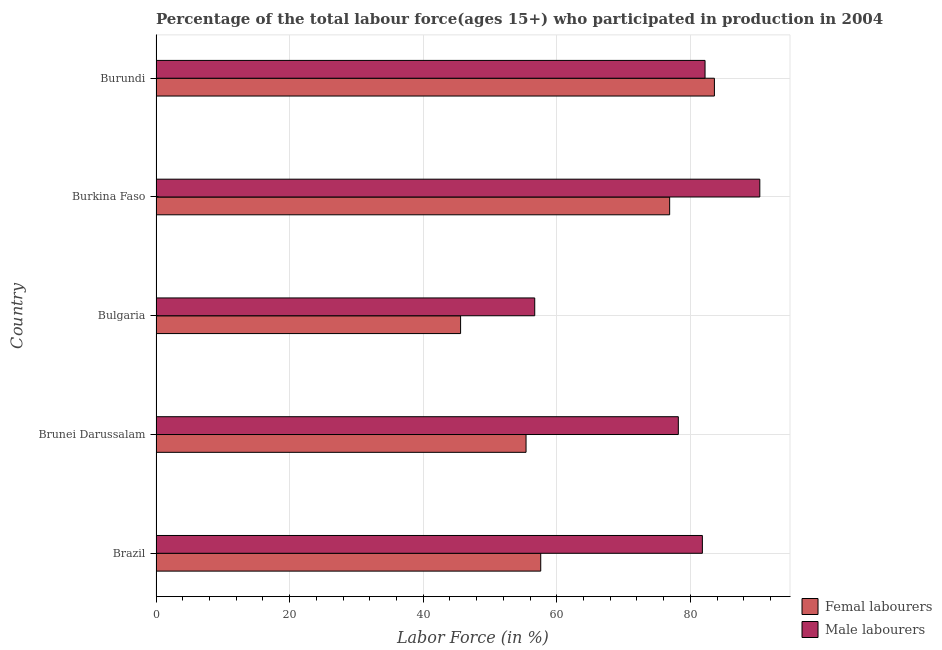How many different coloured bars are there?
Your response must be concise. 2. Are the number of bars per tick equal to the number of legend labels?
Offer a very short reply. Yes. How many bars are there on the 3rd tick from the bottom?
Give a very brief answer. 2. What is the label of the 2nd group of bars from the top?
Your answer should be compact. Burkina Faso. What is the percentage of female labor force in Burkina Faso?
Provide a short and direct response. 76.9. Across all countries, what is the maximum percentage of male labour force?
Provide a short and direct response. 90.4. Across all countries, what is the minimum percentage of female labor force?
Offer a terse response. 45.6. In which country was the percentage of female labor force maximum?
Your answer should be very brief. Burundi. What is the total percentage of male labour force in the graph?
Your answer should be compact. 389.3. What is the difference between the percentage of male labour force in Burkina Faso and that in Burundi?
Ensure brevity in your answer.  8.2. What is the difference between the percentage of female labor force in Burundi and the percentage of male labour force in Bulgaria?
Make the answer very short. 26.9. What is the average percentage of female labor force per country?
Offer a very short reply. 63.82. What is the ratio of the percentage of female labor force in Brazil to that in Burkina Faso?
Offer a terse response. 0.75. Is the percentage of male labour force in Brunei Darussalam less than that in Burundi?
Make the answer very short. Yes. What is the difference between the highest and the second highest percentage of female labor force?
Offer a very short reply. 6.7. What does the 1st bar from the top in Brazil represents?
Ensure brevity in your answer.  Male labourers. What does the 2nd bar from the bottom in Bulgaria represents?
Your answer should be compact. Male labourers. Are all the bars in the graph horizontal?
Your answer should be compact. Yes. How many countries are there in the graph?
Your response must be concise. 5. Are the values on the major ticks of X-axis written in scientific E-notation?
Ensure brevity in your answer.  No. How many legend labels are there?
Keep it short and to the point. 2. How are the legend labels stacked?
Provide a succinct answer. Vertical. What is the title of the graph?
Offer a terse response. Percentage of the total labour force(ages 15+) who participated in production in 2004. Does "Fertility rate" appear as one of the legend labels in the graph?
Ensure brevity in your answer.  No. What is the Labor Force (in %) in Femal labourers in Brazil?
Offer a very short reply. 57.6. What is the Labor Force (in %) in Male labourers in Brazil?
Make the answer very short. 81.8. What is the Labor Force (in %) of Femal labourers in Brunei Darussalam?
Your answer should be compact. 55.4. What is the Labor Force (in %) of Male labourers in Brunei Darussalam?
Provide a succinct answer. 78.2. What is the Labor Force (in %) of Femal labourers in Bulgaria?
Your response must be concise. 45.6. What is the Labor Force (in %) in Male labourers in Bulgaria?
Your response must be concise. 56.7. What is the Labor Force (in %) of Femal labourers in Burkina Faso?
Your answer should be very brief. 76.9. What is the Labor Force (in %) in Male labourers in Burkina Faso?
Offer a terse response. 90.4. What is the Labor Force (in %) in Femal labourers in Burundi?
Provide a succinct answer. 83.6. What is the Labor Force (in %) in Male labourers in Burundi?
Make the answer very short. 82.2. Across all countries, what is the maximum Labor Force (in %) of Femal labourers?
Keep it short and to the point. 83.6. Across all countries, what is the maximum Labor Force (in %) of Male labourers?
Offer a terse response. 90.4. Across all countries, what is the minimum Labor Force (in %) of Femal labourers?
Your answer should be compact. 45.6. Across all countries, what is the minimum Labor Force (in %) of Male labourers?
Keep it short and to the point. 56.7. What is the total Labor Force (in %) in Femal labourers in the graph?
Offer a terse response. 319.1. What is the total Labor Force (in %) of Male labourers in the graph?
Your response must be concise. 389.3. What is the difference between the Labor Force (in %) in Femal labourers in Brazil and that in Bulgaria?
Ensure brevity in your answer.  12. What is the difference between the Labor Force (in %) of Male labourers in Brazil and that in Bulgaria?
Provide a succinct answer. 25.1. What is the difference between the Labor Force (in %) in Femal labourers in Brazil and that in Burkina Faso?
Make the answer very short. -19.3. What is the difference between the Labor Force (in %) in Femal labourers in Brazil and that in Burundi?
Keep it short and to the point. -26. What is the difference between the Labor Force (in %) of Male labourers in Brazil and that in Burundi?
Offer a very short reply. -0.4. What is the difference between the Labor Force (in %) of Male labourers in Brunei Darussalam and that in Bulgaria?
Your answer should be very brief. 21.5. What is the difference between the Labor Force (in %) in Femal labourers in Brunei Darussalam and that in Burkina Faso?
Ensure brevity in your answer.  -21.5. What is the difference between the Labor Force (in %) of Femal labourers in Brunei Darussalam and that in Burundi?
Make the answer very short. -28.2. What is the difference between the Labor Force (in %) of Femal labourers in Bulgaria and that in Burkina Faso?
Make the answer very short. -31.3. What is the difference between the Labor Force (in %) in Male labourers in Bulgaria and that in Burkina Faso?
Provide a short and direct response. -33.7. What is the difference between the Labor Force (in %) in Femal labourers in Bulgaria and that in Burundi?
Keep it short and to the point. -38. What is the difference between the Labor Force (in %) of Male labourers in Bulgaria and that in Burundi?
Keep it short and to the point. -25.5. What is the difference between the Labor Force (in %) in Femal labourers in Brazil and the Labor Force (in %) in Male labourers in Brunei Darussalam?
Make the answer very short. -20.6. What is the difference between the Labor Force (in %) in Femal labourers in Brazil and the Labor Force (in %) in Male labourers in Burkina Faso?
Provide a succinct answer. -32.8. What is the difference between the Labor Force (in %) of Femal labourers in Brazil and the Labor Force (in %) of Male labourers in Burundi?
Your answer should be very brief. -24.6. What is the difference between the Labor Force (in %) of Femal labourers in Brunei Darussalam and the Labor Force (in %) of Male labourers in Bulgaria?
Your response must be concise. -1.3. What is the difference between the Labor Force (in %) of Femal labourers in Brunei Darussalam and the Labor Force (in %) of Male labourers in Burkina Faso?
Provide a succinct answer. -35. What is the difference between the Labor Force (in %) of Femal labourers in Brunei Darussalam and the Labor Force (in %) of Male labourers in Burundi?
Ensure brevity in your answer.  -26.8. What is the difference between the Labor Force (in %) in Femal labourers in Bulgaria and the Labor Force (in %) in Male labourers in Burkina Faso?
Provide a succinct answer. -44.8. What is the difference between the Labor Force (in %) of Femal labourers in Bulgaria and the Labor Force (in %) of Male labourers in Burundi?
Offer a very short reply. -36.6. What is the difference between the Labor Force (in %) in Femal labourers in Burkina Faso and the Labor Force (in %) in Male labourers in Burundi?
Make the answer very short. -5.3. What is the average Labor Force (in %) of Femal labourers per country?
Keep it short and to the point. 63.82. What is the average Labor Force (in %) in Male labourers per country?
Offer a very short reply. 77.86. What is the difference between the Labor Force (in %) of Femal labourers and Labor Force (in %) of Male labourers in Brazil?
Your response must be concise. -24.2. What is the difference between the Labor Force (in %) in Femal labourers and Labor Force (in %) in Male labourers in Brunei Darussalam?
Your answer should be very brief. -22.8. What is the difference between the Labor Force (in %) in Femal labourers and Labor Force (in %) in Male labourers in Bulgaria?
Give a very brief answer. -11.1. What is the difference between the Labor Force (in %) in Femal labourers and Labor Force (in %) in Male labourers in Burundi?
Your answer should be compact. 1.4. What is the ratio of the Labor Force (in %) of Femal labourers in Brazil to that in Brunei Darussalam?
Provide a short and direct response. 1.04. What is the ratio of the Labor Force (in %) of Male labourers in Brazil to that in Brunei Darussalam?
Your response must be concise. 1.05. What is the ratio of the Labor Force (in %) of Femal labourers in Brazil to that in Bulgaria?
Provide a succinct answer. 1.26. What is the ratio of the Labor Force (in %) in Male labourers in Brazil to that in Bulgaria?
Your answer should be compact. 1.44. What is the ratio of the Labor Force (in %) in Femal labourers in Brazil to that in Burkina Faso?
Provide a succinct answer. 0.75. What is the ratio of the Labor Force (in %) of Male labourers in Brazil to that in Burkina Faso?
Keep it short and to the point. 0.9. What is the ratio of the Labor Force (in %) of Femal labourers in Brazil to that in Burundi?
Ensure brevity in your answer.  0.69. What is the ratio of the Labor Force (in %) of Male labourers in Brazil to that in Burundi?
Your response must be concise. 1. What is the ratio of the Labor Force (in %) in Femal labourers in Brunei Darussalam to that in Bulgaria?
Ensure brevity in your answer.  1.21. What is the ratio of the Labor Force (in %) of Male labourers in Brunei Darussalam to that in Bulgaria?
Offer a very short reply. 1.38. What is the ratio of the Labor Force (in %) in Femal labourers in Brunei Darussalam to that in Burkina Faso?
Ensure brevity in your answer.  0.72. What is the ratio of the Labor Force (in %) of Male labourers in Brunei Darussalam to that in Burkina Faso?
Your response must be concise. 0.86. What is the ratio of the Labor Force (in %) of Femal labourers in Brunei Darussalam to that in Burundi?
Offer a very short reply. 0.66. What is the ratio of the Labor Force (in %) of Male labourers in Brunei Darussalam to that in Burundi?
Your answer should be compact. 0.95. What is the ratio of the Labor Force (in %) of Femal labourers in Bulgaria to that in Burkina Faso?
Ensure brevity in your answer.  0.59. What is the ratio of the Labor Force (in %) of Male labourers in Bulgaria to that in Burkina Faso?
Your answer should be very brief. 0.63. What is the ratio of the Labor Force (in %) of Femal labourers in Bulgaria to that in Burundi?
Ensure brevity in your answer.  0.55. What is the ratio of the Labor Force (in %) in Male labourers in Bulgaria to that in Burundi?
Offer a very short reply. 0.69. What is the ratio of the Labor Force (in %) of Femal labourers in Burkina Faso to that in Burundi?
Offer a terse response. 0.92. What is the ratio of the Labor Force (in %) in Male labourers in Burkina Faso to that in Burundi?
Make the answer very short. 1.1. What is the difference between the highest and the second highest Labor Force (in %) in Male labourers?
Offer a very short reply. 8.2. What is the difference between the highest and the lowest Labor Force (in %) of Male labourers?
Provide a succinct answer. 33.7. 